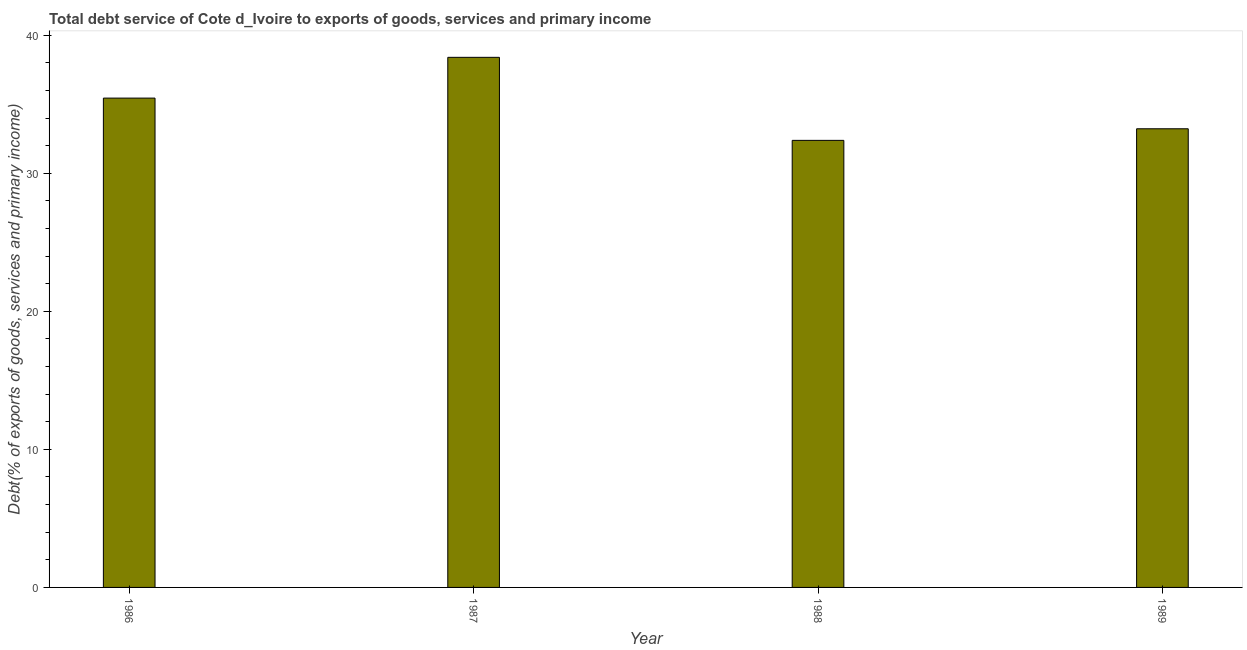Does the graph contain any zero values?
Ensure brevity in your answer.  No. Does the graph contain grids?
Keep it short and to the point. No. What is the title of the graph?
Keep it short and to the point. Total debt service of Cote d_Ivoire to exports of goods, services and primary income. What is the label or title of the Y-axis?
Make the answer very short. Debt(% of exports of goods, services and primary income). What is the total debt service in 1987?
Ensure brevity in your answer.  38.4. Across all years, what is the maximum total debt service?
Offer a terse response. 38.4. Across all years, what is the minimum total debt service?
Make the answer very short. 32.39. What is the sum of the total debt service?
Ensure brevity in your answer.  139.46. What is the difference between the total debt service in 1986 and 1989?
Offer a terse response. 2.22. What is the average total debt service per year?
Your answer should be compact. 34.87. What is the median total debt service?
Ensure brevity in your answer.  34.34. Do a majority of the years between 1986 and 1987 (inclusive) have total debt service greater than 30 %?
Provide a succinct answer. Yes. What is the ratio of the total debt service in 1988 to that in 1989?
Your response must be concise. 0.97. Is the total debt service in 1986 less than that in 1989?
Offer a terse response. No. What is the difference between the highest and the second highest total debt service?
Your answer should be very brief. 2.95. What is the difference between the highest and the lowest total debt service?
Give a very brief answer. 6.01. What is the difference between two consecutive major ticks on the Y-axis?
Offer a very short reply. 10. What is the Debt(% of exports of goods, services and primary income) in 1986?
Your answer should be very brief. 35.45. What is the Debt(% of exports of goods, services and primary income) of 1987?
Your response must be concise. 38.4. What is the Debt(% of exports of goods, services and primary income) of 1988?
Ensure brevity in your answer.  32.39. What is the Debt(% of exports of goods, services and primary income) of 1989?
Provide a succinct answer. 33.23. What is the difference between the Debt(% of exports of goods, services and primary income) in 1986 and 1987?
Offer a terse response. -2.95. What is the difference between the Debt(% of exports of goods, services and primary income) in 1986 and 1988?
Provide a short and direct response. 3.06. What is the difference between the Debt(% of exports of goods, services and primary income) in 1986 and 1989?
Your answer should be very brief. 2.22. What is the difference between the Debt(% of exports of goods, services and primary income) in 1987 and 1988?
Provide a short and direct response. 6.01. What is the difference between the Debt(% of exports of goods, services and primary income) in 1987 and 1989?
Keep it short and to the point. 5.18. What is the difference between the Debt(% of exports of goods, services and primary income) in 1988 and 1989?
Provide a short and direct response. -0.84. What is the ratio of the Debt(% of exports of goods, services and primary income) in 1986 to that in 1987?
Provide a short and direct response. 0.92. What is the ratio of the Debt(% of exports of goods, services and primary income) in 1986 to that in 1988?
Ensure brevity in your answer.  1.09. What is the ratio of the Debt(% of exports of goods, services and primary income) in 1986 to that in 1989?
Keep it short and to the point. 1.07. What is the ratio of the Debt(% of exports of goods, services and primary income) in 1987 to that in 1988?
Give a very brief answer. 1.19. What is the ratio of the Debt(% of exports of goods, services and primary income) in 1987 to that in 1989?
Your response must be concise. 1.16. 